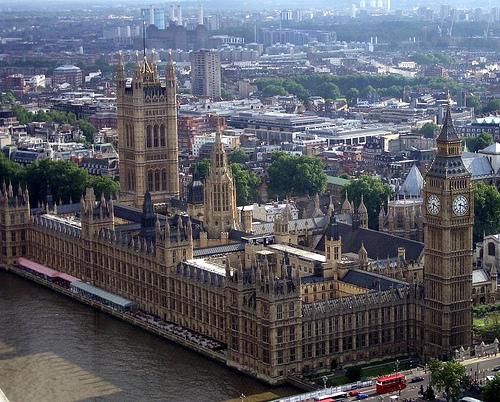What is on the face of the tower?
Concise answer only. Clock. What is the name of the river?
Keep it brief. Thames. What is this building?
Concise answer only. Parliament. What city is this located in?
Short answer required. London. 